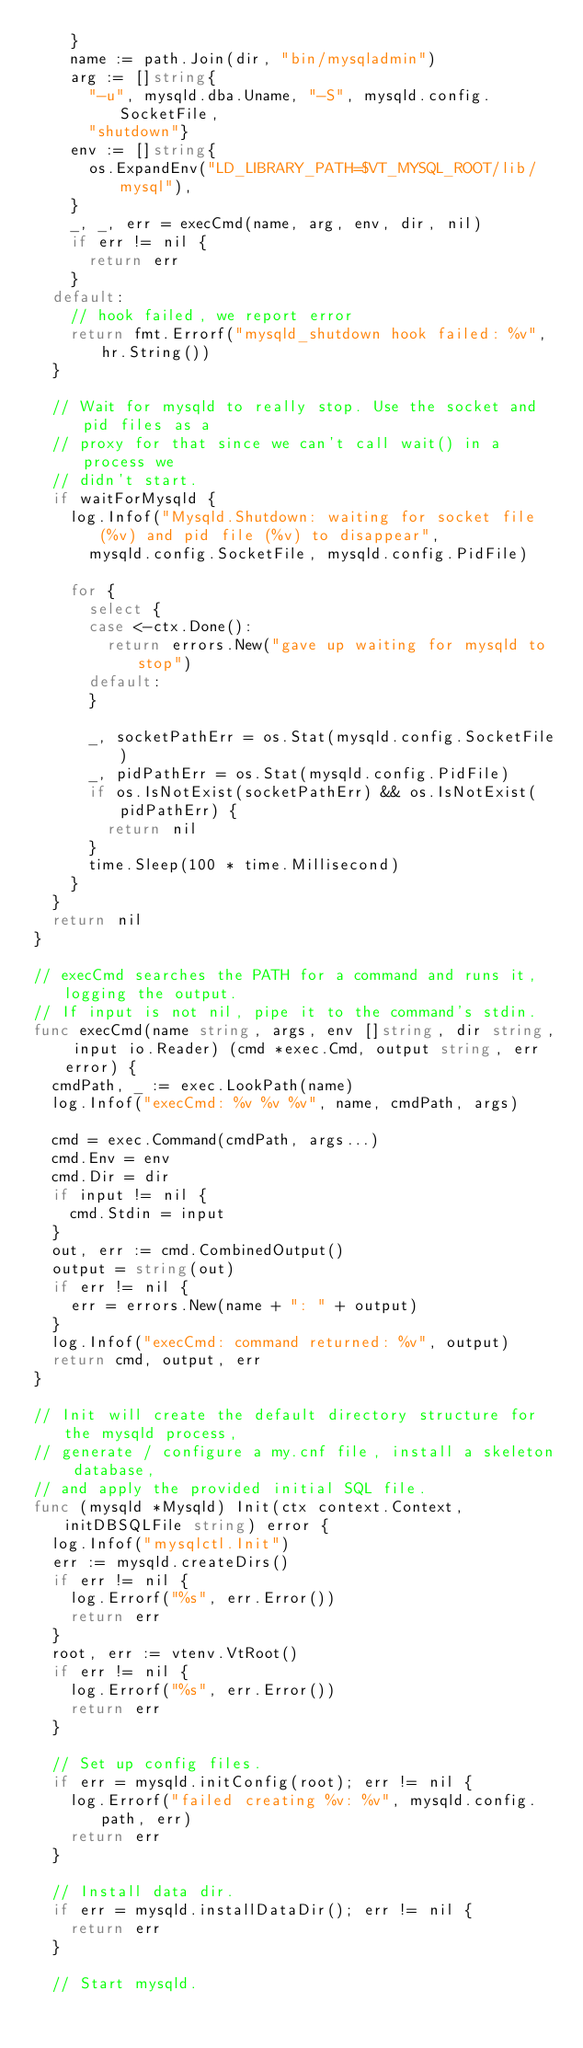<code> <loc_0><loc_0><loc_500><loc_500><_Go_>		}
		name := path.Join(dir, "bin/mysqladmin")
		arg := []string{
			"-u", mysqld.dba.Uname, "-S", mysqld.config.SocketFile,
			"shutdown"}
		env := []string{
			os.ExpandEnv("LD_LIBRARY_PATH=$VT_MYSQL_ROOT/lib/mysql"),
		}
		_, _, err = execCmd(name, arg, env, dir, nil)
		if err != nil {
			return err
		}
	default:
		// hook failed, we report error
		return fmt.Errorf("mysqld_shutdown hook failed: %v", hr.String())
	}

	// Wait for mysqld to really stop. Use the socket and pid files as a
	// proxy for that since we can't call wait() in a process we
	// didn't start.
	if waitForMysqld {
		log.Infof("Mysqld.Shutdown: waiting for socket file (%v) and pid file (%v) to disappear",
			mysqld.config.SocketFile, mysqld.config.PidFile)

		for {
			select {
			case <-ctx.Done():
				return errors.New("gave up waiting for mysqld to stop")
			default:
			}

			_, socketPathErr = os.Stat(mysqld.config.SocketFile)
			_, pidPathErr = os.Stat(mysqld.config.PidFile)
			if os.IsNotExist(socketPathErr) && os.IsNotExist(pidPathErr) {
				return nil
			}
			time.Sleep(100 * time.Millisecond)
		}
	}
	return nil
}

// execCmd searches the PATH for a command and runs it, logging the output.
// If input is not nil, pipe it to the command's stdin.
func execCmd(name string, args, env []string, dir string, input io.Reader) (cmd *exec.Cmd, output string, err error) {
	cmdPath, _ := exec.LookPath(name)
	log.Infof("execCmd: %v %v %v", name, cmdPath, args)

	cmd = exec.Command(cmdPath, args...)
	cmd.Env = env
	cmd.Dir = dir
	if input != nil {
		cmd.Stdin = input
	}
	out, err := cmd.CombinedOutput()
	output = string(out)
	if err != nil {
		err = errors.New(name + ": " + output)
	}
	log.Infof("execCmd: command returned: %v", output)
	return cmd, output, err
}

// Init will create the default directory structure for the mysqld process,
// generate / configure a my.cnf file, install a skeleton database,
// and apply the provided initial SQL file.
func (mysqld *Mysqld) Init(ctx context.Context, initDBSQLFile string) error {
	log.Infof("mysqlctl.Init")
	err := mysqld.createDirs()
	if err != nil {
		log.Errorf("%s", err.Error())
		return err
	}
	root, err := vtenv.VtRoot()
	if err != nil {
		log.Errorf("%s", err.Error())
		return err
	}

	// Set up config files.
	if err = mysqld.initConfig(root); err != nil {
		log.Errorf("failed creating %v: %v", mysqld.config.path, err)
		return err
	}

	// Install data dir.
	if err = mysqld.installDataDir(); err != nil {
		return err
	}

	// Start mysqld.</code> 